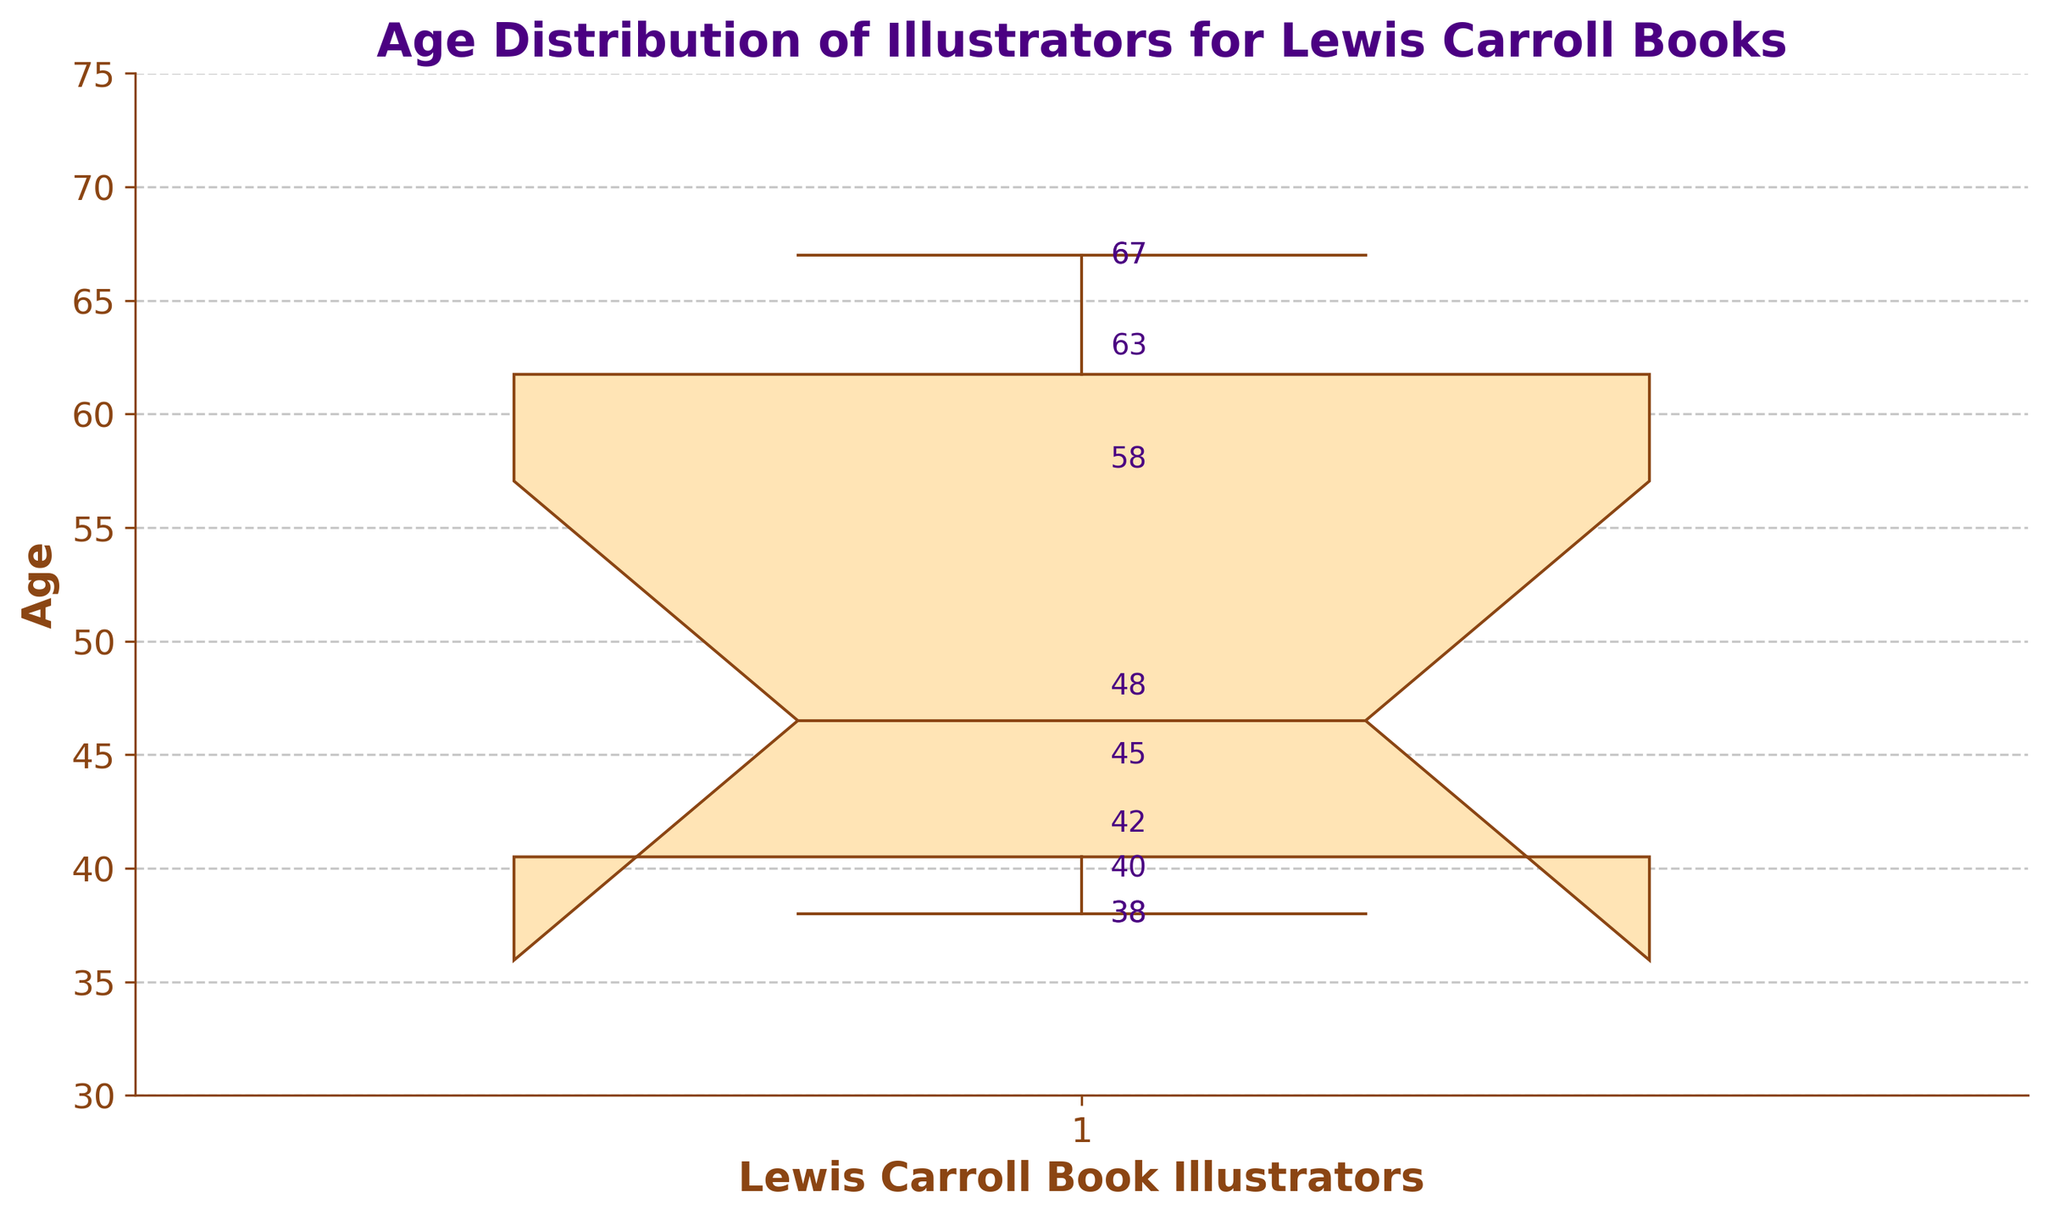What is the title of the plot? The title of the plot is found at the top of the figure. Here, it clearly states "Age Distribution of Illustrators for Lewis Carroll Books".
Answer: Age Distribution of Illustrators for Lewis Carroll Books What are the minimum and maximum ages of the illustrators? The whiskers of the box plot indicate the minimum and maximum values. The minimum is 38 and the maximum is 67.
Answer: Minimum: 38, Maximum: 67 What is the median age of the illustrators? The median is represented by the line inside the box. In this case, it is at the value of 45.
Answer: 45 How many data points are there in the plot? Each age value represents a data point. By counting the annotated age numbers, we see there are 10 data points.
Answer: 10 Which illustrator is the oldest, and what is their age? The highest point on the plot represents the oldest illustrator. The annotation at 67 specifies this, which corresponds to Quentin Blake and Ralph Steadman.
Answer: Quentin Blake and Ralph Steadman, 67 What is the interquartile range (IQR) of the illustrators' ages? The IQR is the value between the first quartile (Q1) and the third quartile (Q3). From the plot, Q1 is around 40 and Q3 is about 58. The IQR is calculated as 58 - 40.
Answer: 18 Are there any outliers in the age data? In a notched box plot, outliers would be represented as points outside the "whiskers". In this plot, there are no additional points beyond the whiskers, indicating no outliers.
Answer: No How does the notched portion of the box plot help in understanding the data? The notch around the median helps to visualize the confidence interval of the median. If notches between box plots do not overlap, it suggests a statistically significant difference between medians. Here, with only one box plot, this feature emphasizes the spread around the median.
Answer: It shows the confidence interval around the median What age value has the smallest annotation on the plot and whose age is that? The smallest annotated age value on the plot is 38. It corresponds to Marjorie Torrey and Rory Dobner.
Answer: Marjorie Torrey and Rory Dobner, 38 What is the overall distribution shape suggested by the box plot? The box plot indicates a right-skewed distribution, with the median closer to the lower quartile and a longer whisker toward higher ages.
Answer: Right-skewed 